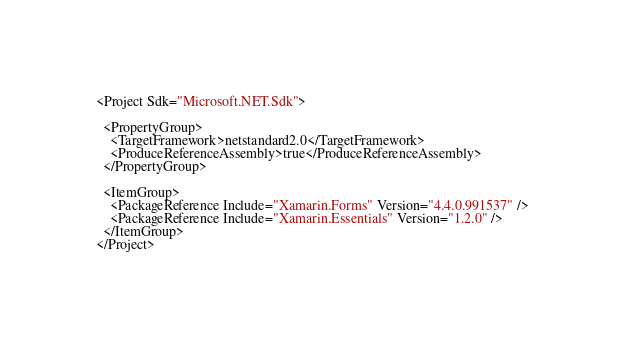<code> <loc_0><loc_0><loc_500><loc_500><_XML_><Project Sdk="Microsoft.NET.Sdk">

  <PropertyGroup>
    <TargetFramework>netstandard2.0</TargetFramework>
    <ProduceReferenceAssembly>true</ProduceReferenceAssembly>
  </PropertyGroup>

  <ItemGroup>
    <PackageReference Include="Xamarin.Forms" Version="4.4.0.991537" />
    <PackageReference Include="Xamarin.Essentials" Version="1.2.0" />
  </ItemGroup>
</Project></code> 